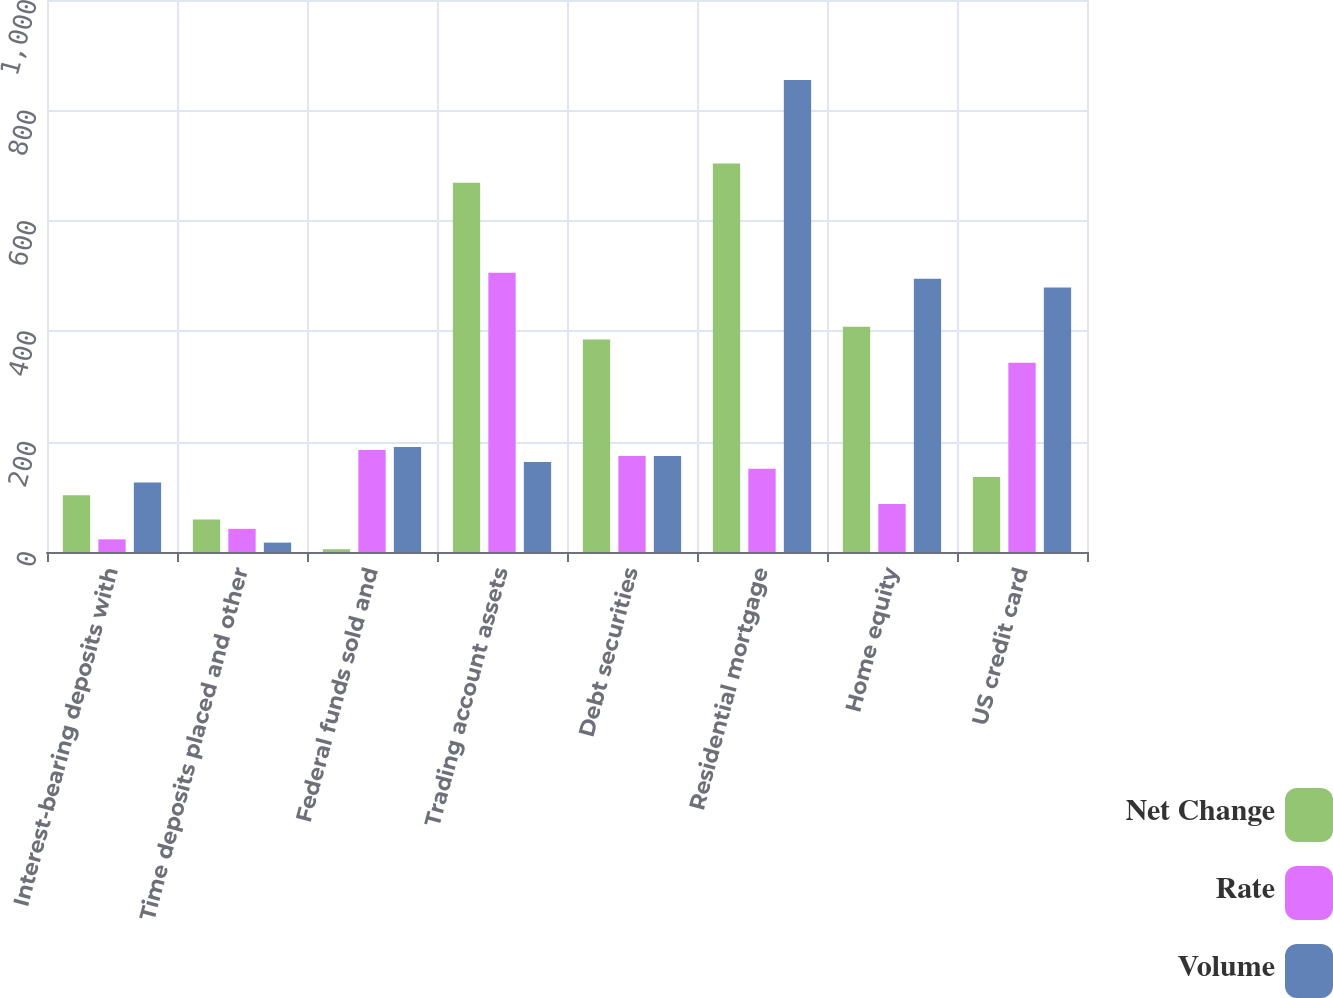Convert chart. <chart><loc_0><loc_0><loc_500><loc_500><stacked_bar_chart><ecel><fcel>Interest-bearing deposits with<fcel>Time deposits placed and other<fcel>Federal funds sold and<fcel>Trading account assets<fcel>Debt securities<fcel>Residential mortgage<fcel>Home equity<fcel>US credit card<nl><fcel>Net Change<fcel>103<fcel>59<fcel>5<fcel>669<fcel>385<fcel>704<fcel>408<fcel>136<nl><fcel>Rate<fcel>23<fcel>42<fcel>185<fcel>506<fcel>174<fcel>151<fcel>87<fcel>343<nl><fcel>Volume<fcel>126<fcel>17<fcel>190<fcel>163<fcel>174<fcel>855<fcel>495<fcel>479<nl></chart> 